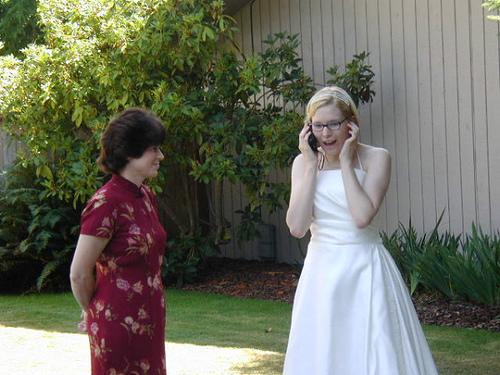Identify the nearby objects and their respective positions associated with the phone call. A pair of eyeglasses is located near the bride's face, and she is covering her other ear with her hand to hear the person on the phone better. Count and describe the dresses in the image. There are three dresses: a long silk white wedding dress, a red dress with a collar and flower pattern, and a burgandy dress on another woman. What type of fence is present in the image, and what color is it? There is a tall brown wooden fence in the image. Analyze the interaction between the bride and the woman with black hair. The bride is excited to talk to someone on the phone, while the woman with black hair, possibly the bride's mother, is happily watching her daughter. Count and briefly describe the prominent objects or items in the image. There are 9 prominent objects: two dresses, a cell phone, eyeglasses, a fence, leaves on the ground, bamboo, and bushes near the house. Provide a brief description of two main characters in the image and their actions. A young blonde bride is talking on a small black cell phone, and a woman with short black hair wearing an oriental-style maroon dress is watching her with hands behind her back. Describe the probable relationship between the two women in the image. The women might be the bride and her mother, or two close friends, as they are observing each other and sharing a happy moment. Identify the scene and location of the image. The scene is set in a backyard garden with shrubbery against a building, a stand of bamboo, and a strip covered with mulch. Briefly describe the object the bride is holding and its color. The bride is holding a small black cell phone in her hand. What is the sentiment conveyed by the image? The sentiment is happiness and excitement, as the bride and other woman are smiling and engaged in a positive environment. 